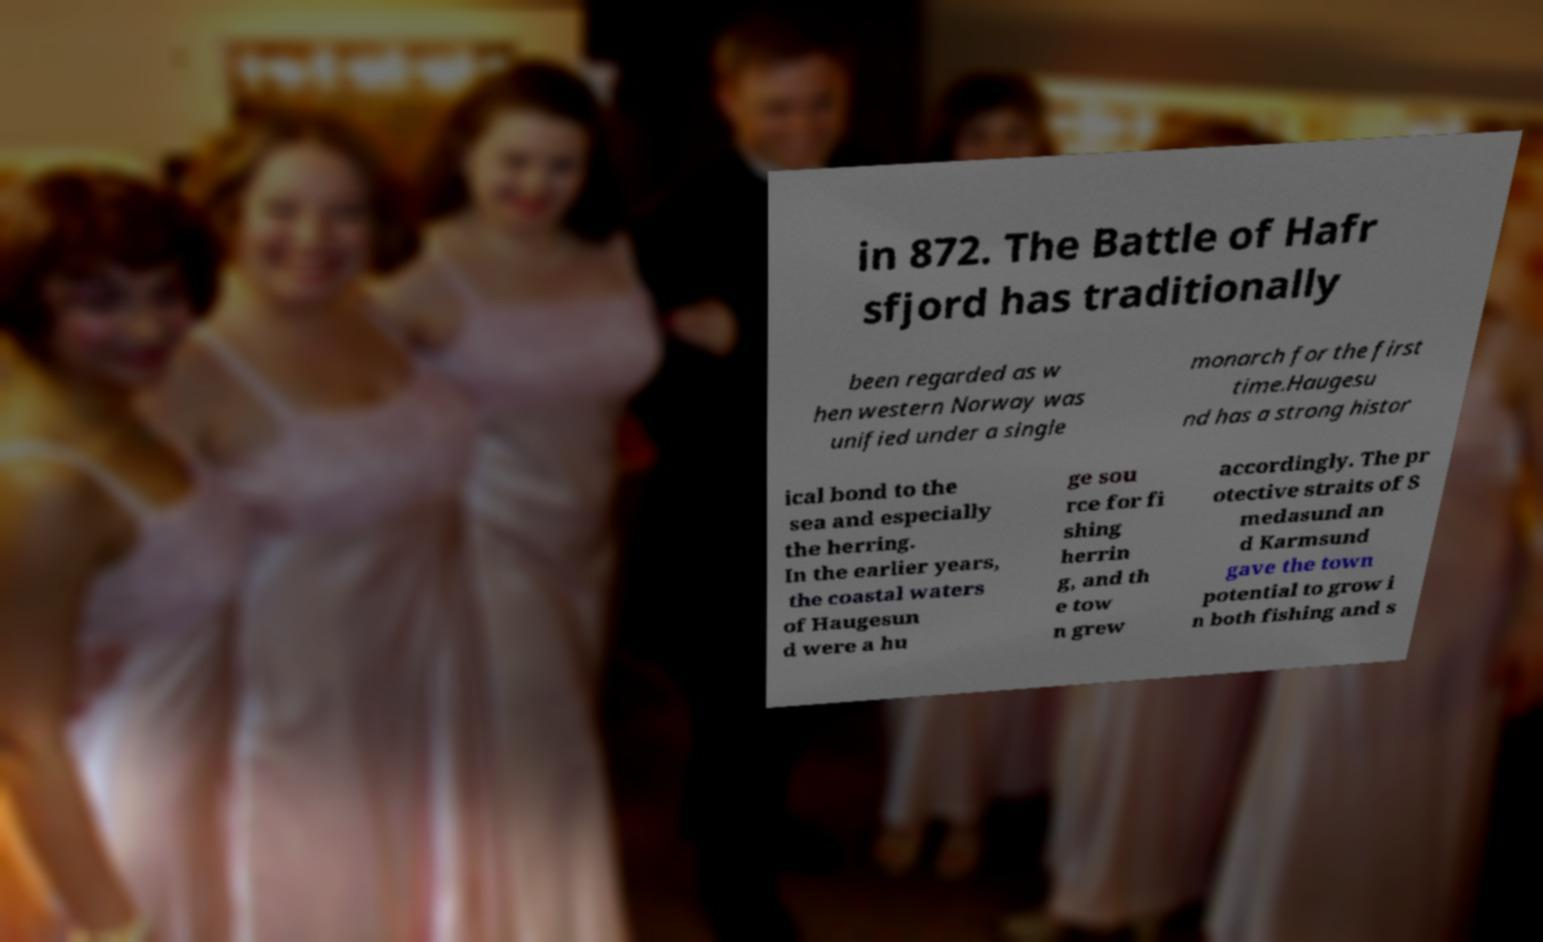What messages or text are displayed in this image? I need them in a readable, typed format. in 872. The Battle of Hafr sfjord has traditionally been regarded as w hen western Norway was unified under a single monarch for the first time.Haugesu nd has a strong histor ical bond to the sea and especially the herring. In the earlier years, the coastal waters of Haugesun d were a hu ge sou rce for fi shing herrin g, and th e tow n grew accordingly. The pr otective straits of S medasund an d Karmsund gave the town potential to grow i n both fishing and s 